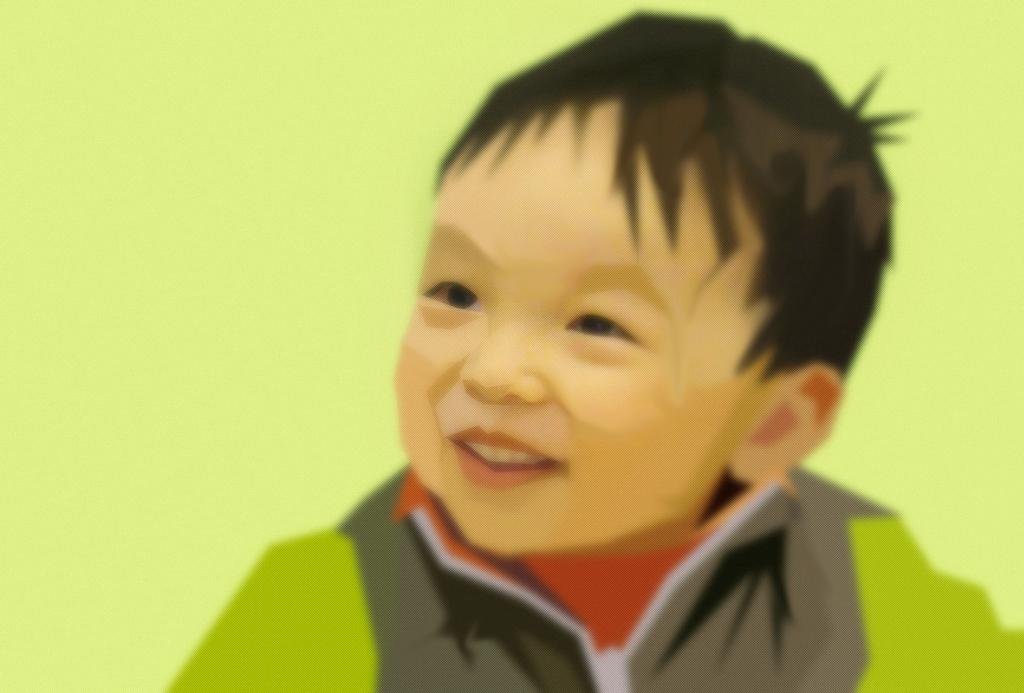What is the main subject of the painting in the image? The main subject of the painting in the image is a boy. What is the boy wearing in the painting? The boy is wearing a green and brown shirt in the painting. What expression does the boy have in the painting? The boy is smiling in the painting. What color is the background of the painting? The background of the painting is green in color. What type of machine is the boy operating in the painting? There is no machine present in the painting; it features a boy wearing a green and brown shirt, smiling, with a green background. 